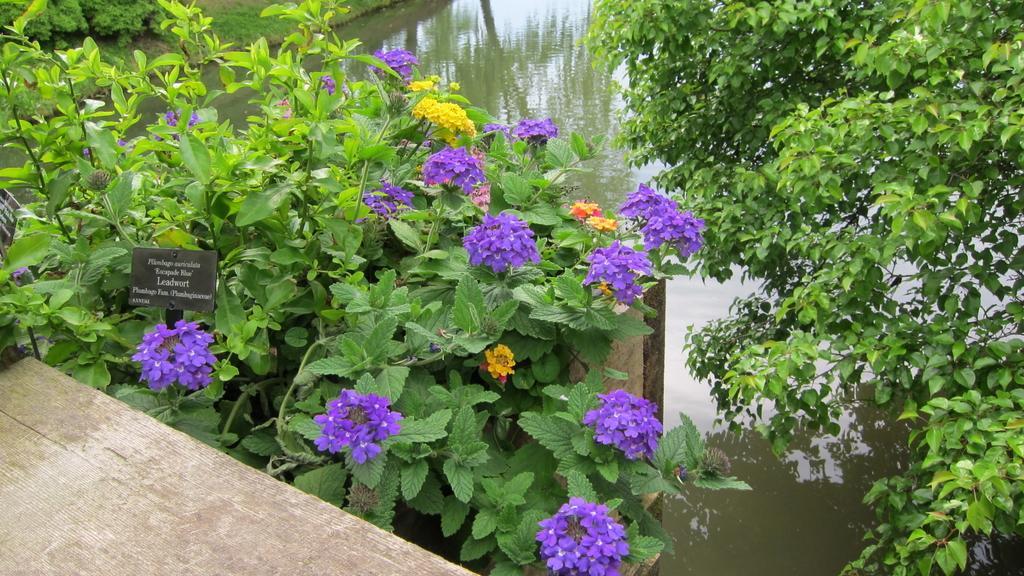How would you summarize this image in a sentence or two? In this picture there is flowers plant in the center of the image and there is another plant in the top right side of the image, there is a dock at the bottom side of the image and there is water in the background area of the image. 